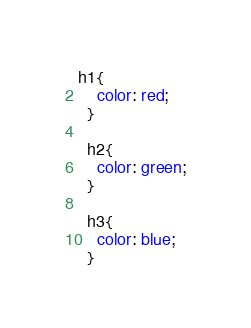<code> <loc_0><loc_0><loc_500><loc_500><_CSS_>h1{
    color: red;
  }
  
  h2{
    color: green;
  }
  
  h3{
    color: blue;
  }</code> 